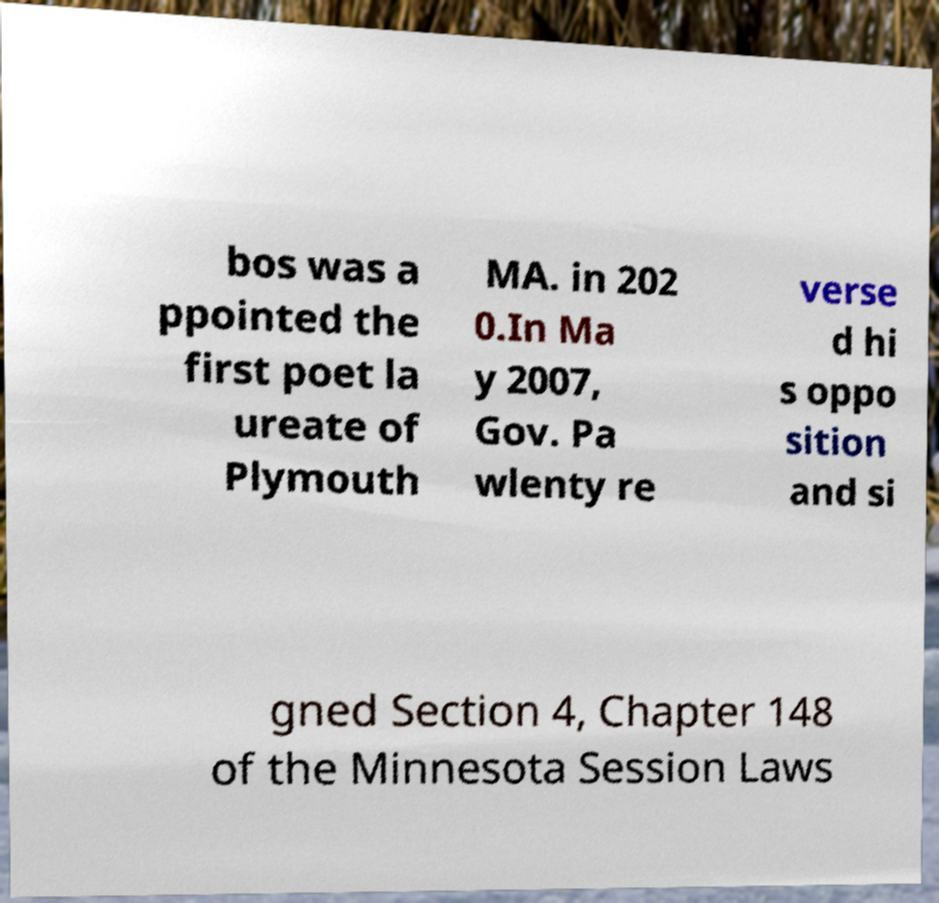What messages or text are displayed in this image? I need them in a readable, typed format. bos was a ppointed the first poet la ureate of Plymouth MA. in 202 0.In Ma y 2007, Gov. Pa wlenty re verse d hi s oppo sition and si gned Section 4, Chapter 148 of the Minnesota Session Laws 